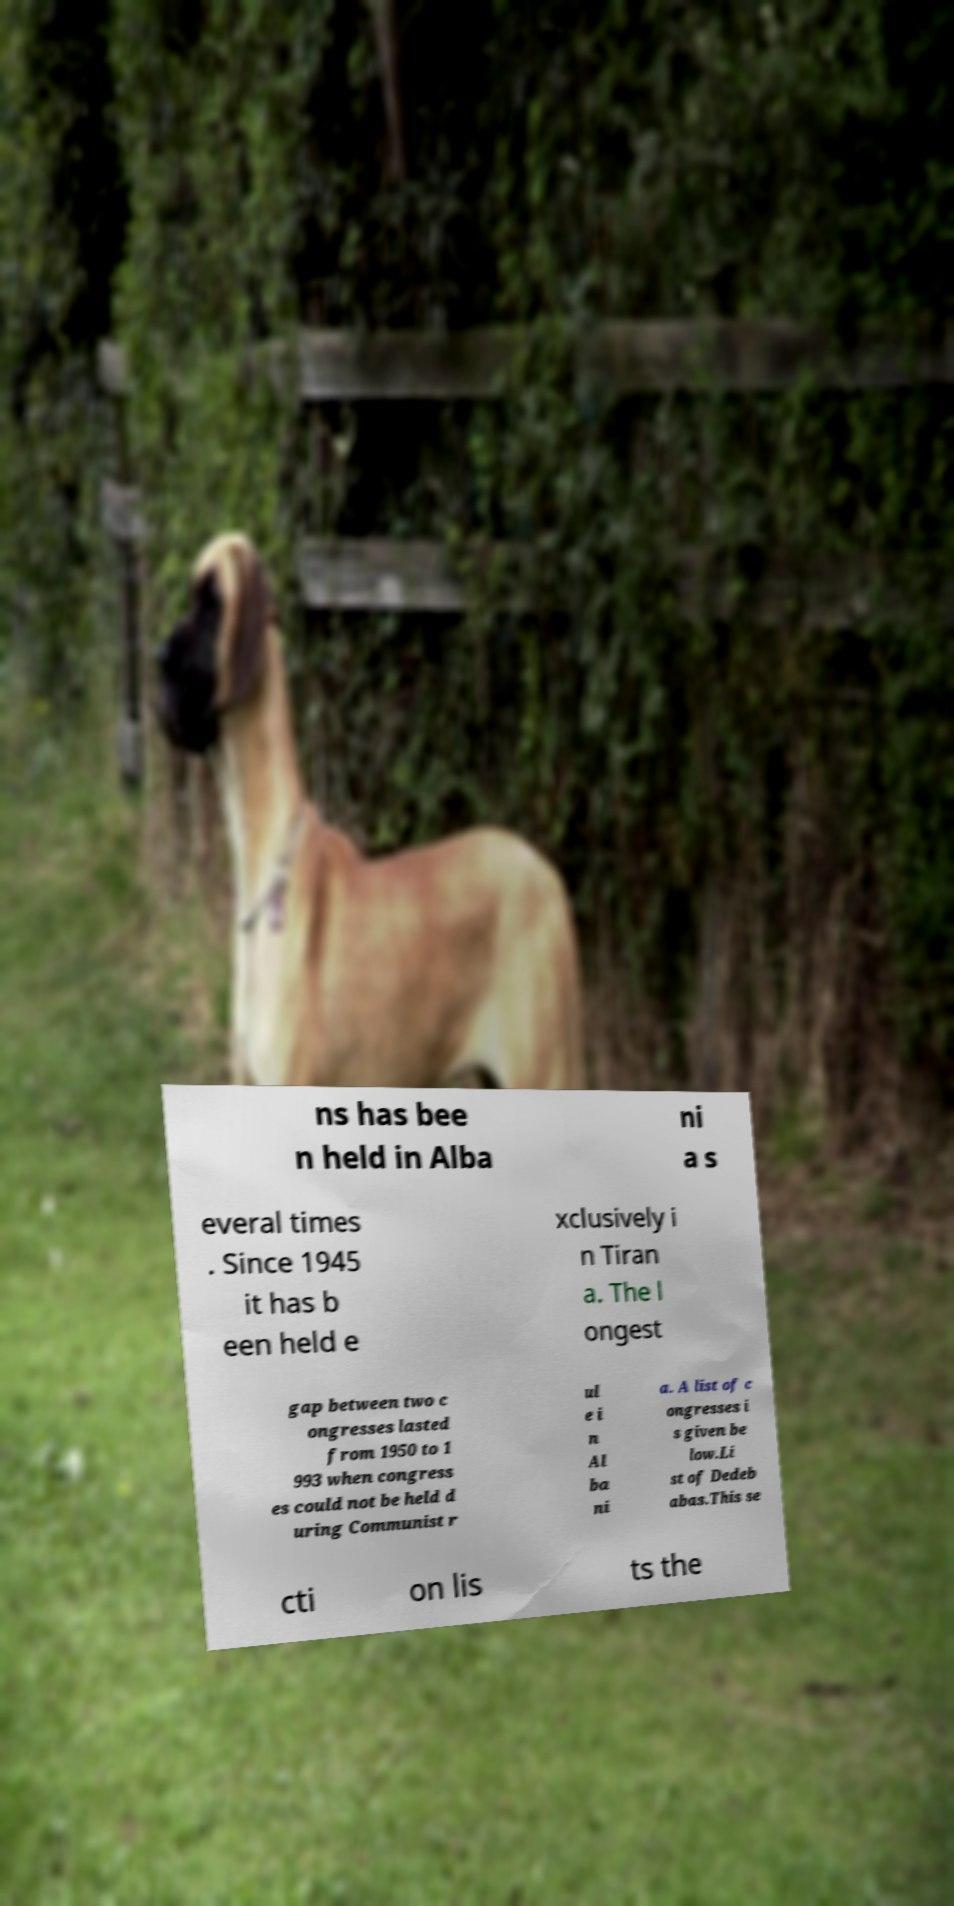Could you assist in decoding the text presented in this image and type it out clearly? ns has bee n held in Alba ni a s everal times . Since 1945 it has b een held e xclusively i n Tiran a. The l ongest gap between two c ongresses lasted from 1950 to 1 993 when congress es could not be held d uring Communist r ul e i n Al ba ni a. A list of c ongresses i s given be low.Li st of Dedeb abas.This se cti on lis ts the 